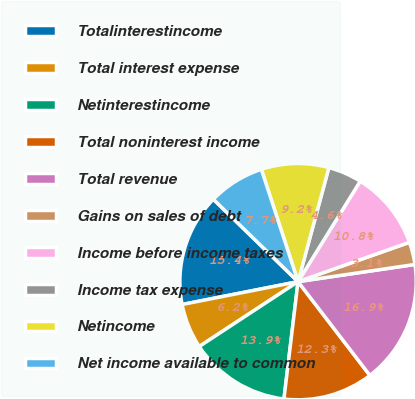<chart> <loc_0><loc_0><loc_500><loc_500><pie_chart><fcel>Totalinterestincome<fcel>Total interest expense<fcel>Netinterestincome<fcel>Total noninterest income<fcel>Total revenue<fcel>Gains on sales of debt<fcel>Income before income taxes<fcel>Income tax expense<fcel>Netincome<fcel>Net income available to common<nl><fcel>15.38%<fcel>6.15%<fcel>13.85%<fcel>12.31%<fcel>16.92%<fcel>3.08%<fcel>10.77%<fcel>4.62%<fcel>9.23%<fcel>7.69%<nl></chart> 